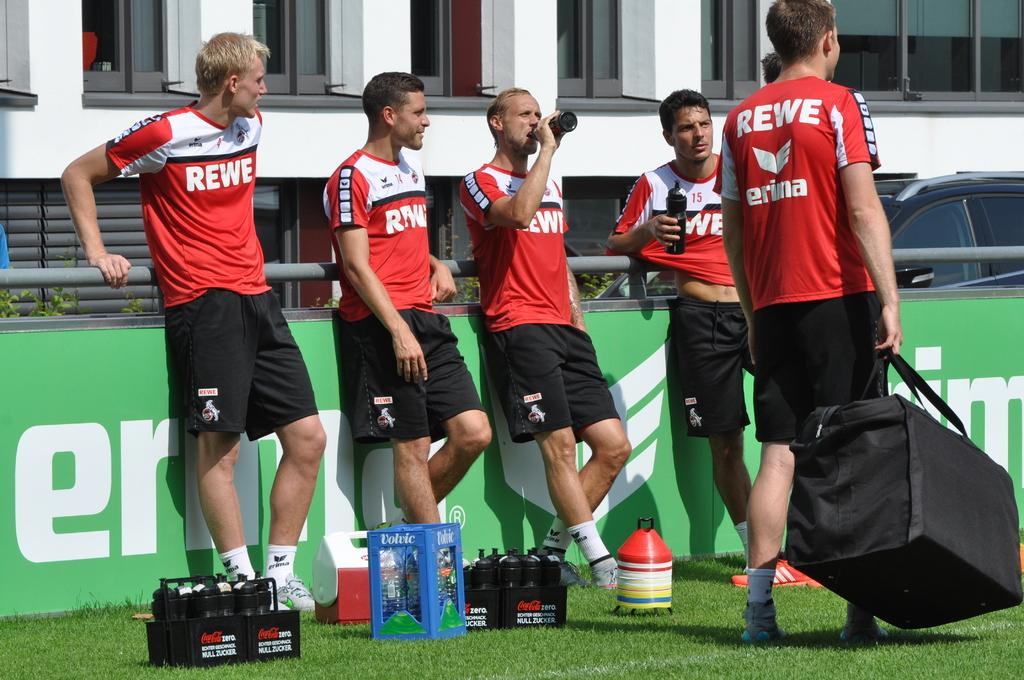Provide a one-sentence caption for the provided image. Soccer players on a field with REWE on their shirts. 